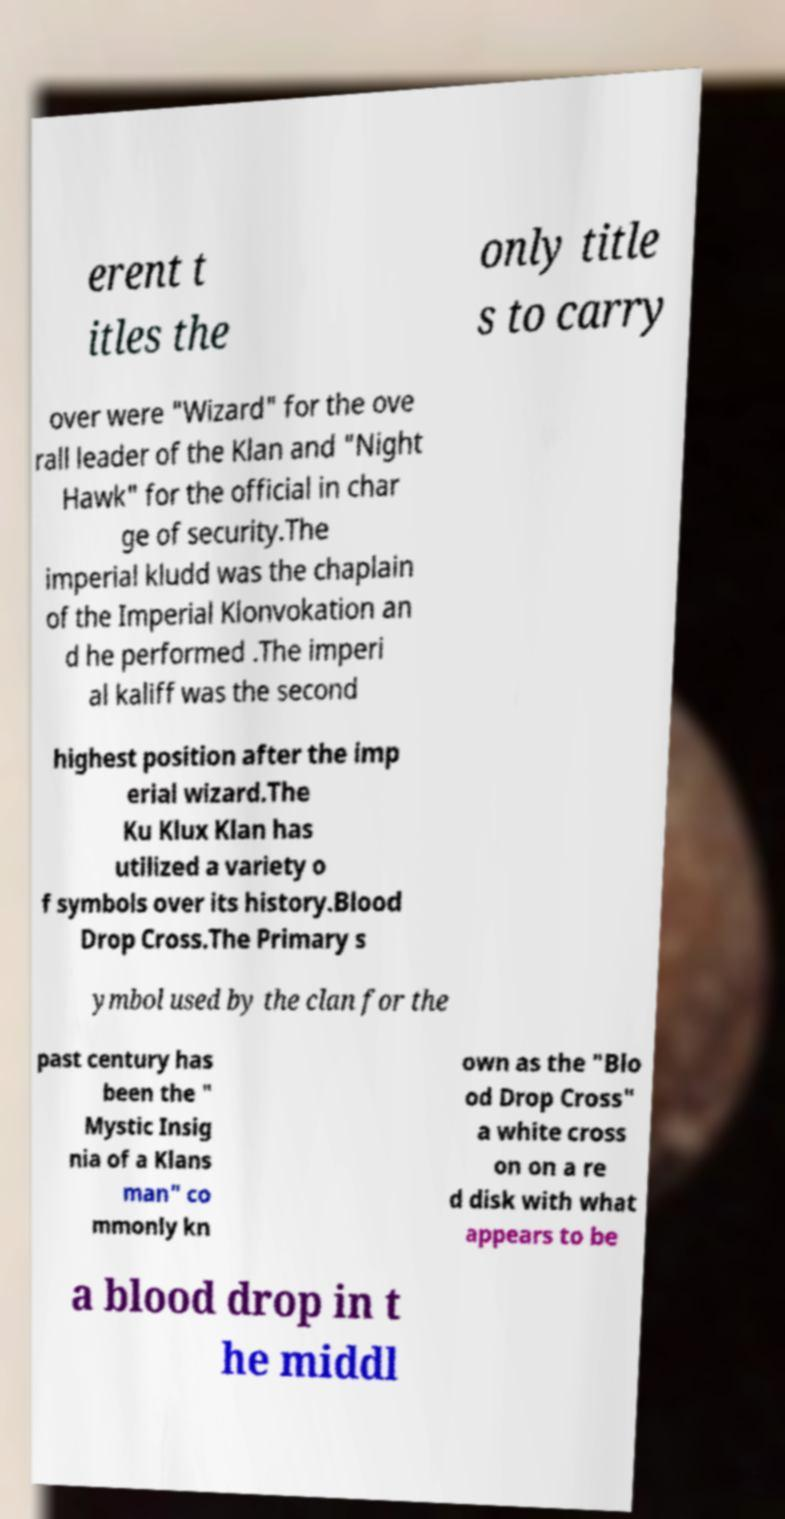For documentation purposes, I need the text within this image transcribed. Could you provide that? erent t itles the only title s to carry over were "Wizard" for the ove rall leader of the Klan and "Night Hawk" for the official in char ge of security.The imperial kludd was the chaplain of the Imperial Klonvokation an d he performed .The imperi al kaliff was the second highest position after the imp erial wizard.The Ku Klux Klan has utilized a variety o f symbols over its history.Blood Drop Cross.The Primary s ymbol used by the clan for the past century has been the " Mystic Insig nia of a Klans man" co mmonly kn own as the "Blo od Drop Cross" a white cross on on a re d disk with what appears to be a blood drop in t he middl 